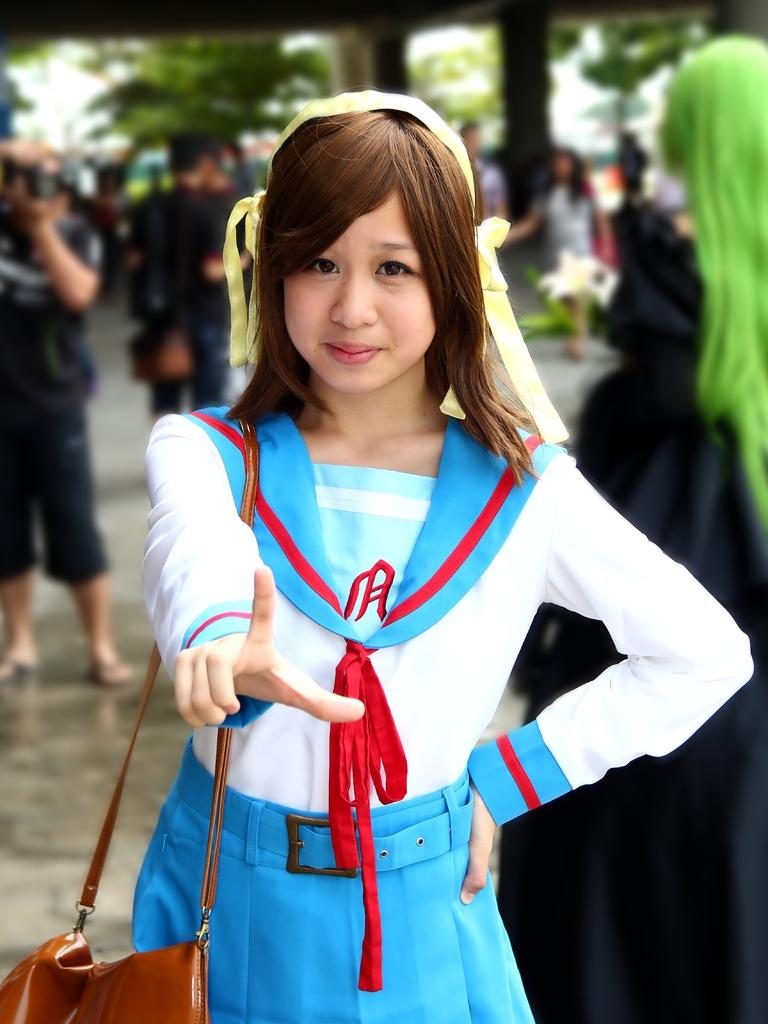Who is the main subject in the image? There is a girl in the image. What is the girl wearing? The girl is wearing a blue and white dress. What is the girl holding in the image? The girl is holding a bag. Can you describe the background of the image? There are many persons behind the girl, and trees are present in the image. What type of knowledge can be seen in the image? There is no knowledge present in the image; it features a girl wearing a blue and white dress, holding a bag, and standing in front of other persons and trees. Can you see a bear in the image? No, there is no bear present in the image. 